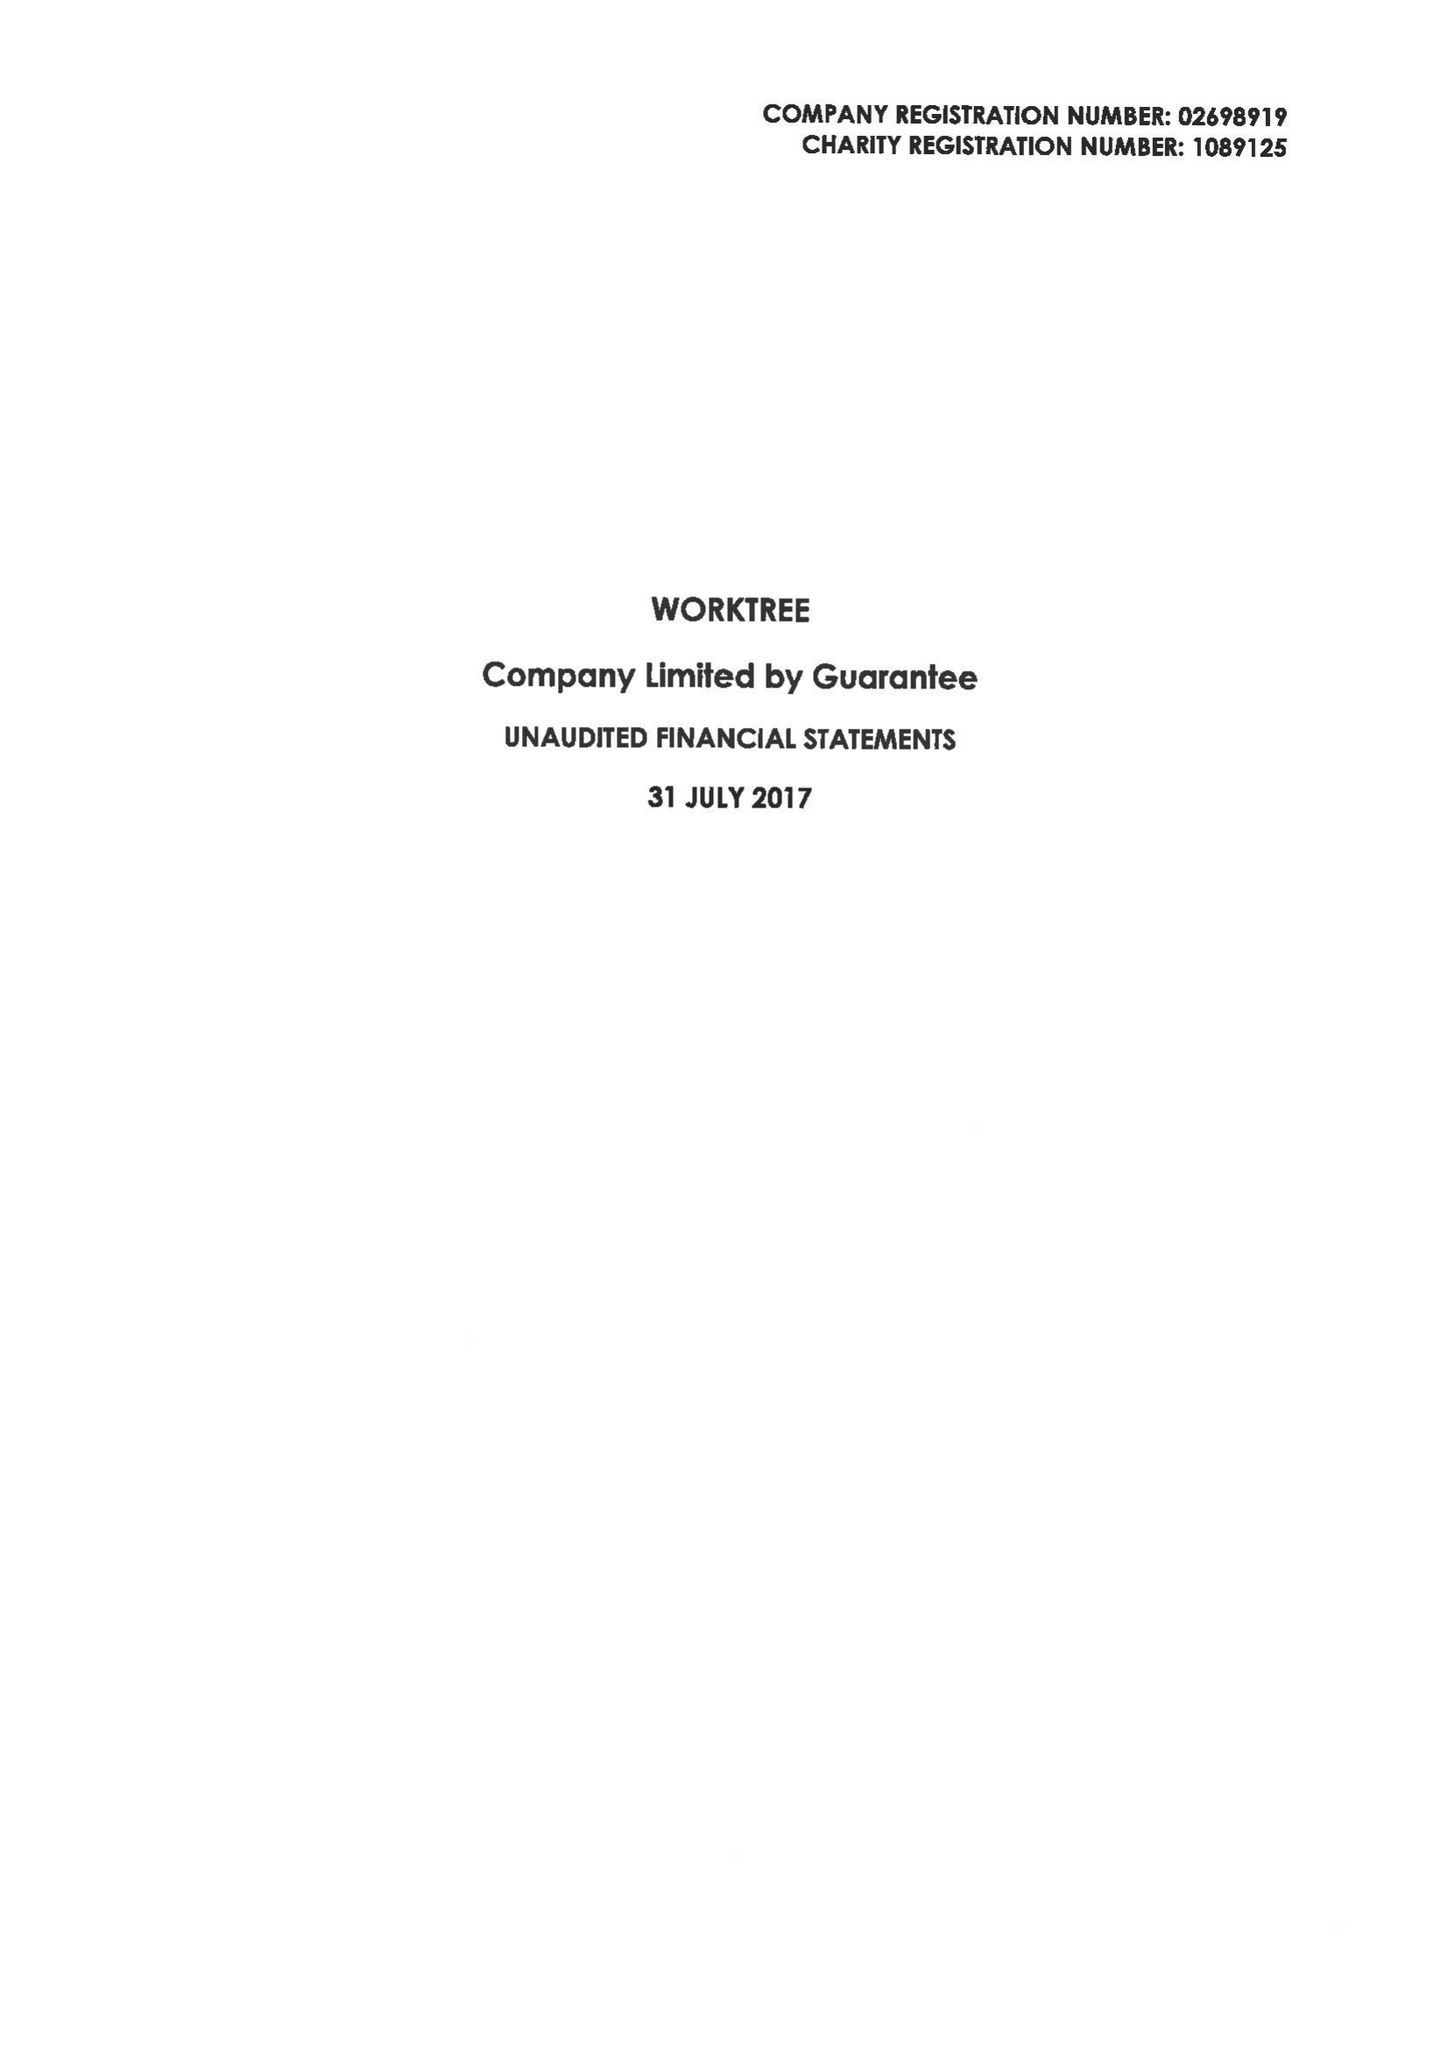What is the value for the charity_number?
Answer the question using a single word or phrase. 1089125 